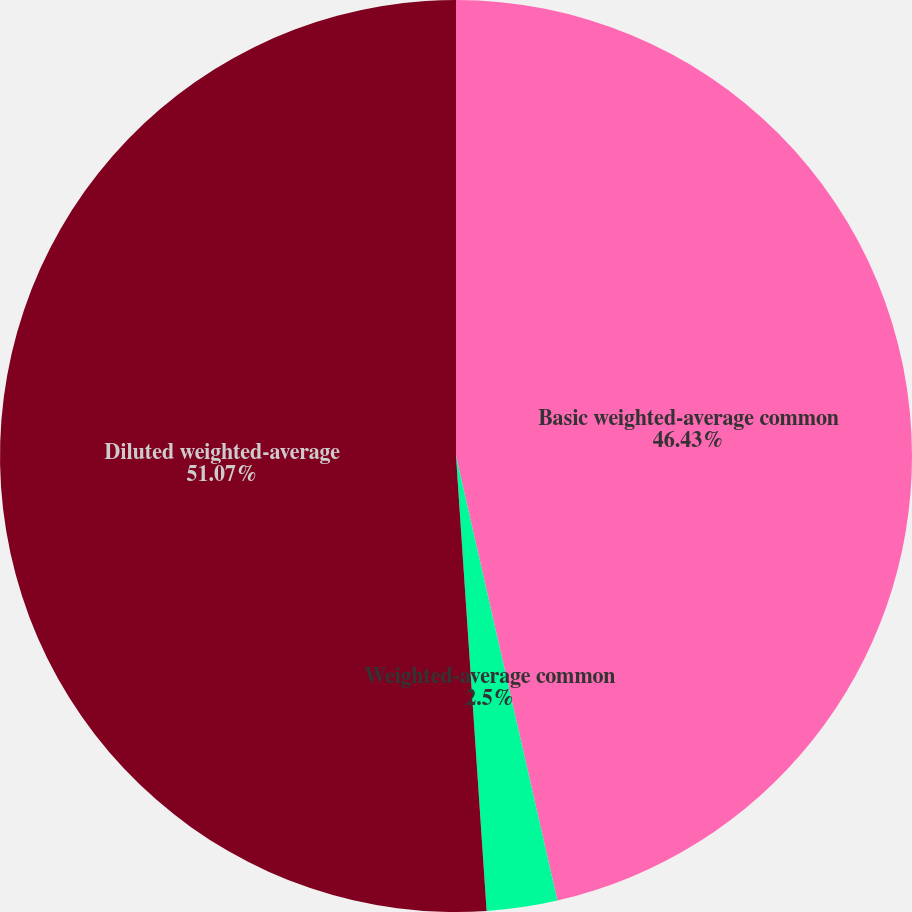Convert chart to OTSL. <chart><loc_0><loc_0><loc_500><loc_500><pie_chart><fcel>Basic weighted-average common<fcel>Weighted-average common<fcel>Diluted weighted-average<nl><fcel>46.43%<fcel>2.5%<fcel>51.07%<nl></chart> 